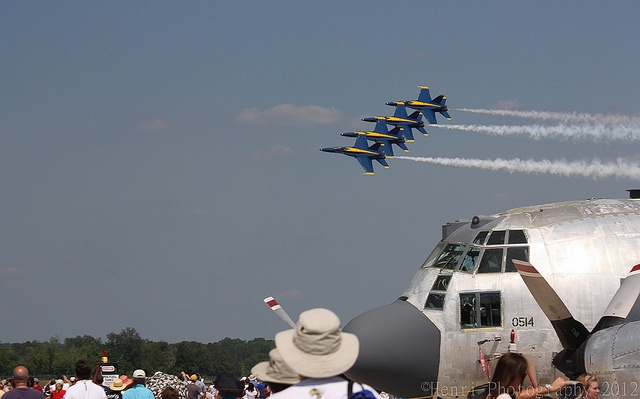Describe the objects in this image and their specific colors. I can see airplane in gray, lightgray, darkgray, and black tones, people in gray, lightgray, darkgray, and tan tones, people in gray, darkgray, tan, and black tones, people in gray, black, maroon, and lightgray tones, and airplane in gray, navy, black, and darkblue tones in this image. 